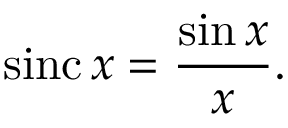Convert formula to latex. <formula><loc_0><loc_0><loc_500><loc_500>\sin c \, x = { \frac { \sin x } { x } } .</formula> 